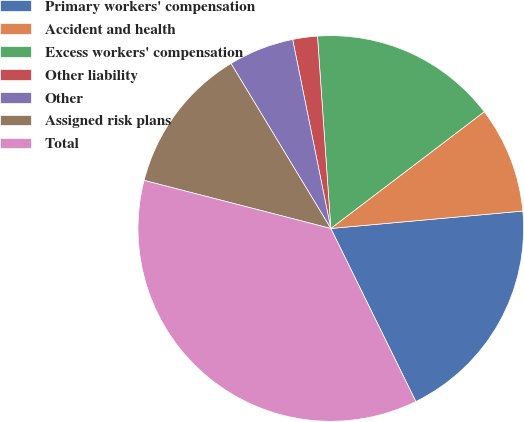<chart> <loc_0><loc_0><loc_500><loc_500><pie_chart><fcel>Primary workers' compensation<fcel>Accident and health<fcel>Excess workers' compensation<fcel>Other liability<fcel>Other<fcel>Assigned risk plans<fcel>Total<nl><fcel>19.17%<fcel>8.91%<fcel>15.75%<fcel>2.07%<fcel>5.49%<fcel>12.33%<fcel>36.28%<nl></chart> 